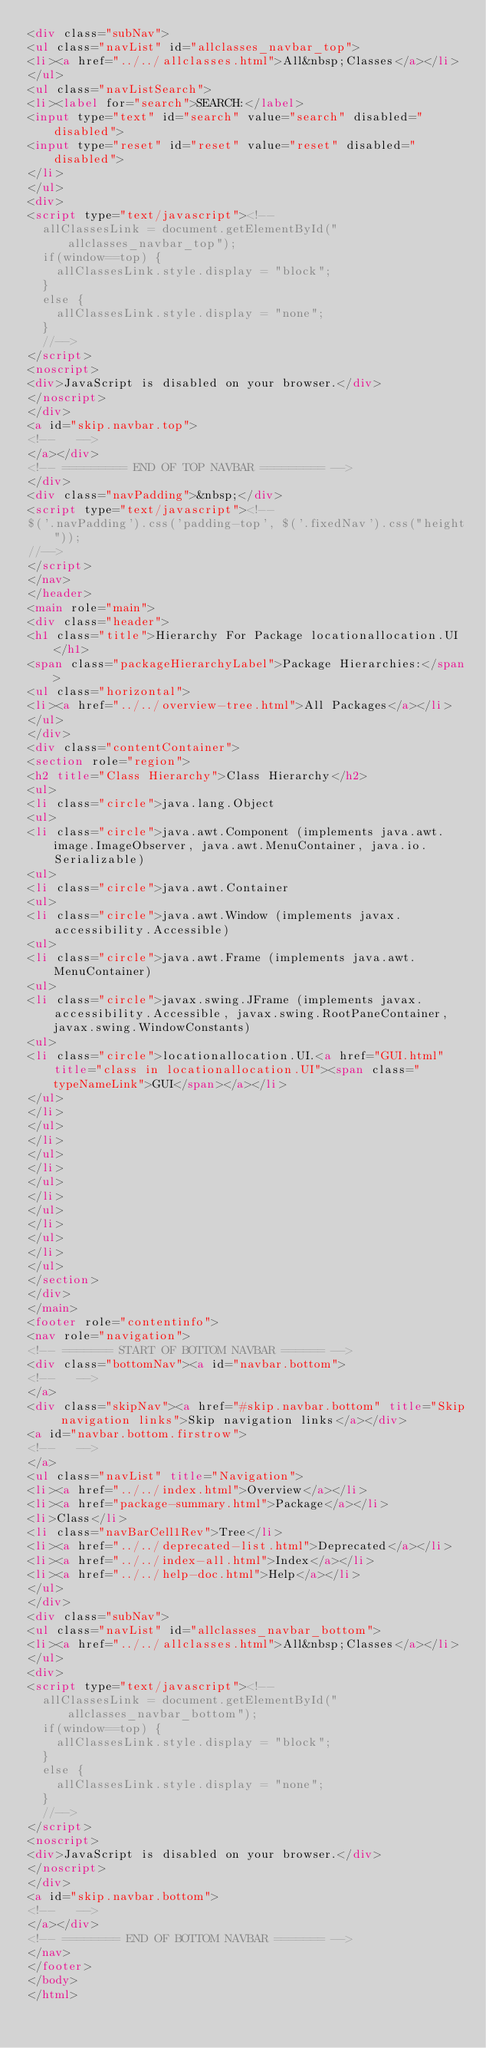Convert code to text. <code><loc_0><loc_0><loc_500><loc_500><_HTML_><div class="subNav">
<ul class="navList" id="allclasses_navbar_top">
<li><a href="../../allclasses.html">All&nbsp;Classes</a></li>
</ul>
<ul class="navListSearch">
<li><label for="search">SEARCH:</label>
<input type="text" id="search" value="search" disabled="disabled">
<input type="reset" id="reset" value="reset" disabled="disabled">
</li>
</ul>
<div>
<script type="text/javascript"><!--
  allClassesLink = document.getElementById("allclasses_navbar_top");
  if(window==top) {
    allClassesLink.style.display = "block";
  }
  else {
    allClassesLink.style.display = "none";
  }
  //-->
</script>
<noscript>
<div>JavaScript is disabled on your browser.</div>
</noscript>
</div>
<a id="skip.navbar.top">
<!--   -->
</a></div>
<!-- ========= END OF TOP NAVBAR ========= -->
</div>
<div class="navPadding">&nbsp;</div>
<script type="text/javascript"><!--
$('.navPadding').css('padding-top', $('.fixedNav').css("height"));
//-->
</script>
</nav>
</header>
<main role="main">
<div class="header">
<h1 class="title">Hierarchy For Package locationallocation.UI</h1>
<span class="packageHierarchyLabel">Package Hierarchies:</span>
<ul class="horizontal">
<li><a href="../../overview-tree.html">All Packages</a></li>
</ul>
</div>
<div class="contentContainer">
<section role="region">
<h2 title="Class Hierarchy">Class Hierarchy</h2>
<ul>
<li class="circle">java.lang.Object
<ul>
<li class="circle">java.awt.Component (implements java.awt.image.ImageObserver, java.awt.MenuContainer, java.io.Serializable)
<ul>
<li class="circle">java.awt.Container
<ul>
<li class="circle">java.awt.Window (implements javax.accessibility.Accessible)
<ul>
<li class="circle">java.awt.Frame (implements java.awt.MenuContainer)
<ul>
<li class="circle">javax.swing.JFrame (implements javax.accessibility.Accessible, javax.swing.RootPaneContainer, javax.swing.WindowConstants)
<ul>
<li class="circle">locationallocation.UI.<a href="GUI.html" title="class in locationallocation.UI"><span class="typeNameLink">GUI</span></a></li>
</ul>
</li>
</ul>
</li>
</ul>
</li>
</ul>
</li>
</ul>
</li>
</ul>
</li>
</ul>
</section>
</div>
</main>
<footer role="contentinfo">
<nav role="navigation">
<!-- ======= START OF BOTTOM NAVBAR ====== -->
<div class="bottomNav"><a id="navbar.bottom">
<!--   -->
</a>
<div class="skipNav"><a href="#skip.navbar.bottom" title="Skip navigation links">Skip navigation links</a></div>
<a id="navbar.bottom.firstrow">
<!--   -->
</a>
<ul class="navList" title="Navigation">
<li><a href="../../index.html">Overview</a></li>
<li><a href="package-summary.html">Package</a></li>
<li>Class</li>
<li class="navBarCell1Rev">Tree</li>
<li><a href="../../deprecated-list.html">Deprecated</a></li>
<li><a href="../../index-all.html">Index</a></li>
<li><a href="../../help-doc.html">Help</a></li>
</ul>
</div>
<div class="subNav">
<ul class="navList" id="allclasses_navbar_bottom">
<li><a href="../../allclasses.html">All&nbsp;Classes</a></li>
</ul>
<div>
<script type="text/javascript"><!--
  allClassesLink = document.getElementById("allclasses_navbar_bottom");
  if(window==top) {
    allClassesLink.style.display = "block";
  }
  else {
    allClassesLink.style.display = "none";
  }
  //-->
</script>
<noscript>
<div>JavaScript is disabled on your browser.</div>
</noscript>
</div>
<a id="skip.navbar.bottom">
<!--   -->
</a></div>
<!-- ======== END OF BOTTOM NAVBAR ======= -->
</nav>
</footer>
</body>
</html>
</code> 